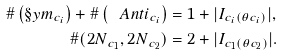Convert formula to latex. <formula><loc_0><loc_0><loc_500><loc_500>\# \left ( \S y m _ { c _ { i } } \right ) + \# \left ( \ A n t i _ { c _ { i } } \right ) & = 1 + | I _ { c _ { i } ( \theta c _ { i } ) } | , \\ \# ( { 2 N } _ { c _ { 1 } } , { 2 N } _ { c _ { 2 } } ) & = 2 + | I _ { c _ { 1 } ( \theta c _ { 2 } ) } | .</formula> 